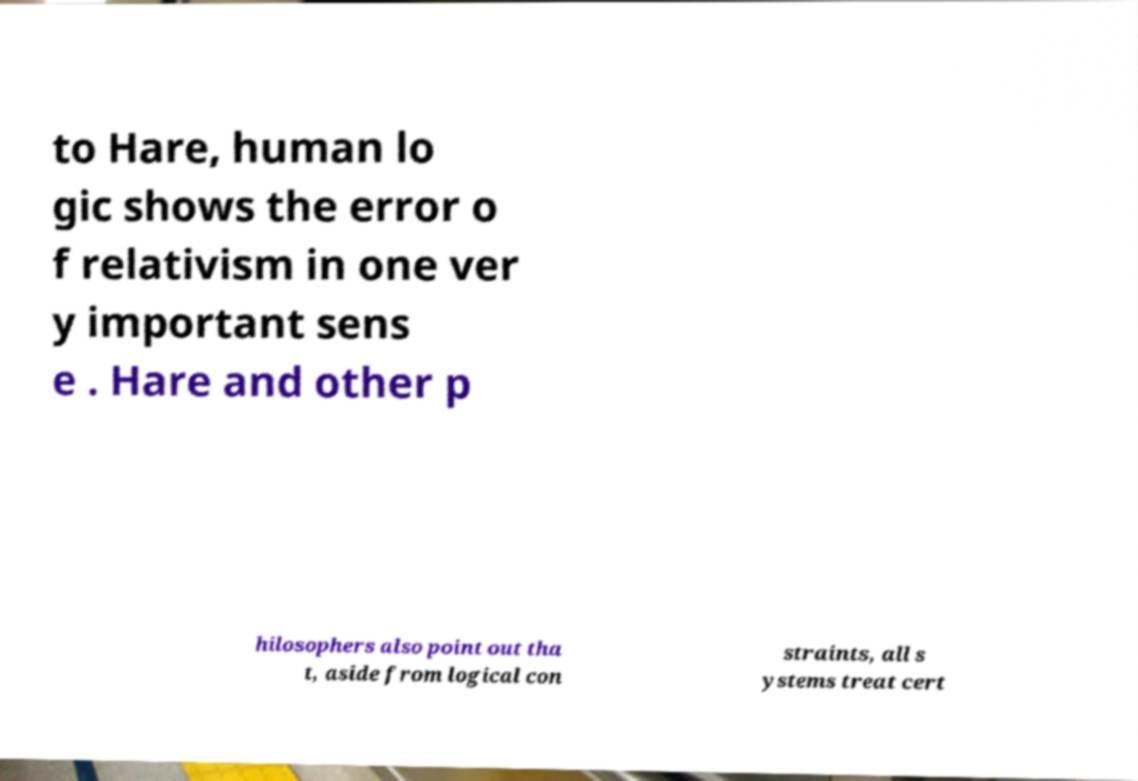Could you assist in decoding the text presented in this image and type it out clearly? to Hare, human lo gic shows the error o f relativism in one ver y important sens e . Hare and other p hilosophers also point out tha t, aside from logical con straints, all s ystems treat cert 